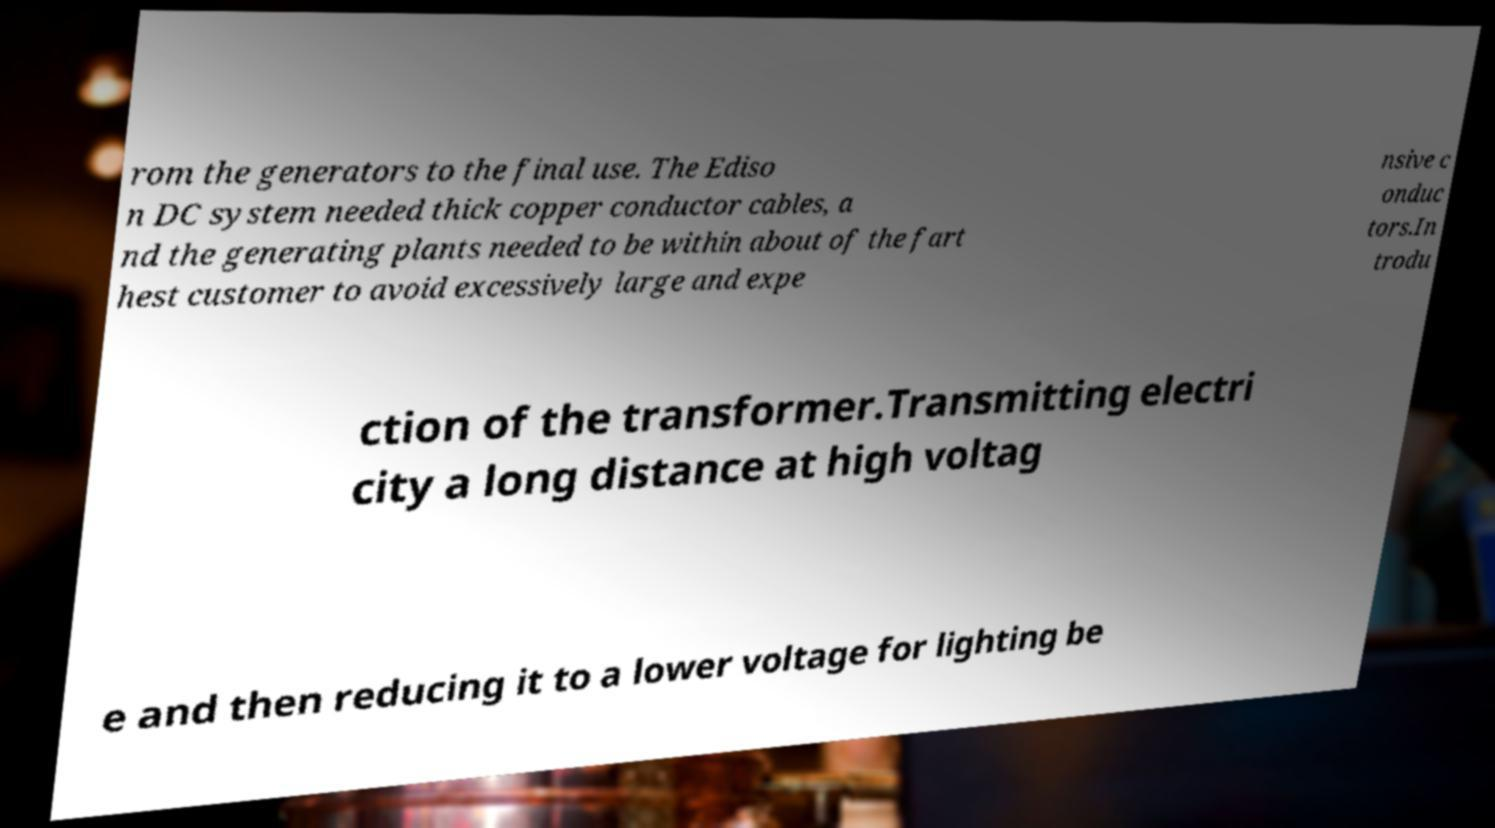Please read and relay the text visible in this image. What does it say? rom the generators to the final use. The Ediso n DC system needed thick copper conductor cables, a nd the generating plants needed to be within about of the fart hest customer to avoid excessively large and expe nsive c onduc tors.In trodu ction of the transformer.Transmitting electri city a long distance at high voltag e and then reducing it to a lower voltage for lighting be 